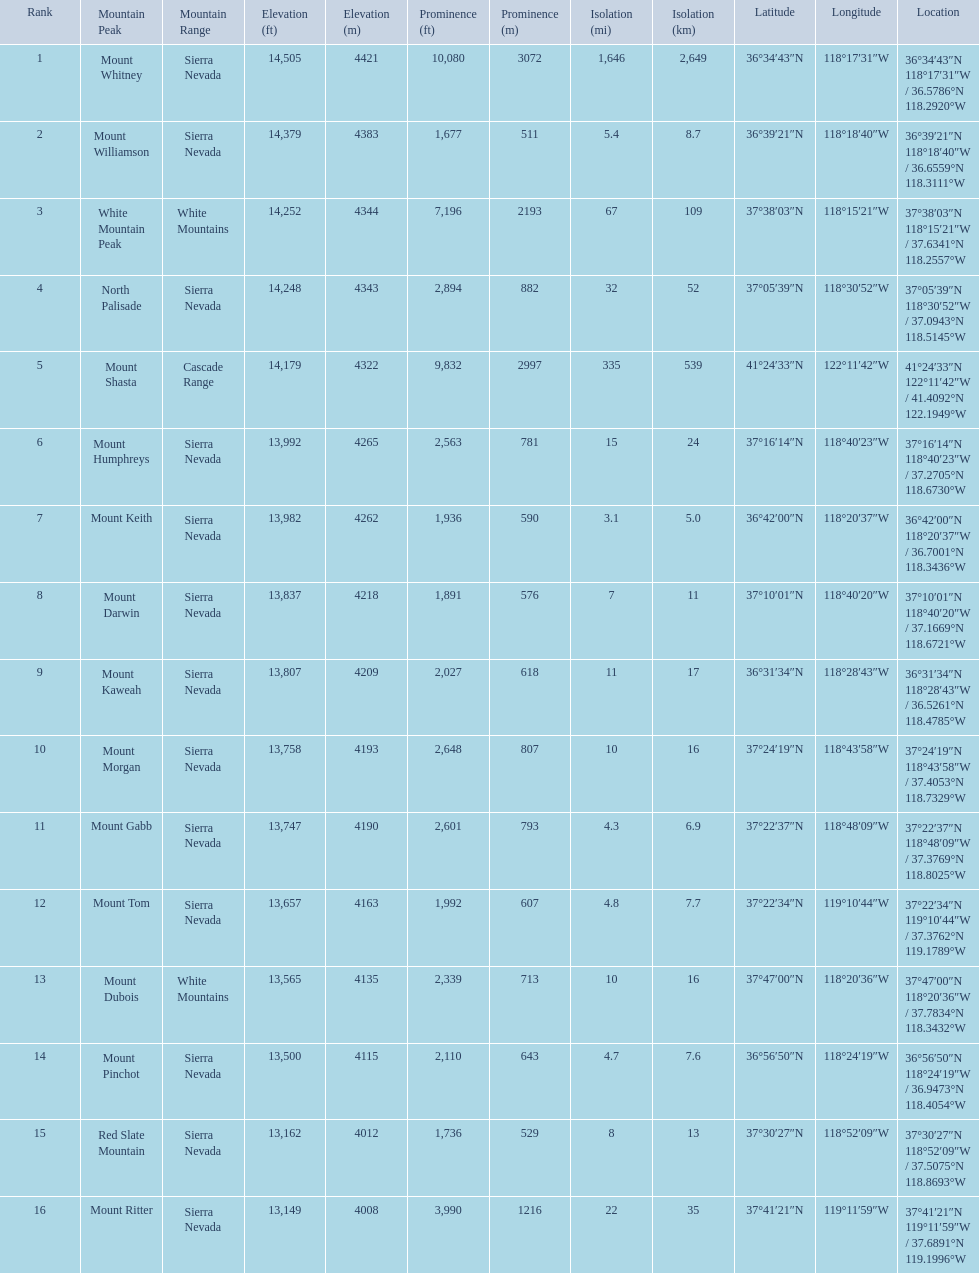What are the prominence lengths higher than 10,000 feet? 10,080 ft\n3072 m. What mountain peak has a prominence of 10,080 feet? Mount Whitney. 